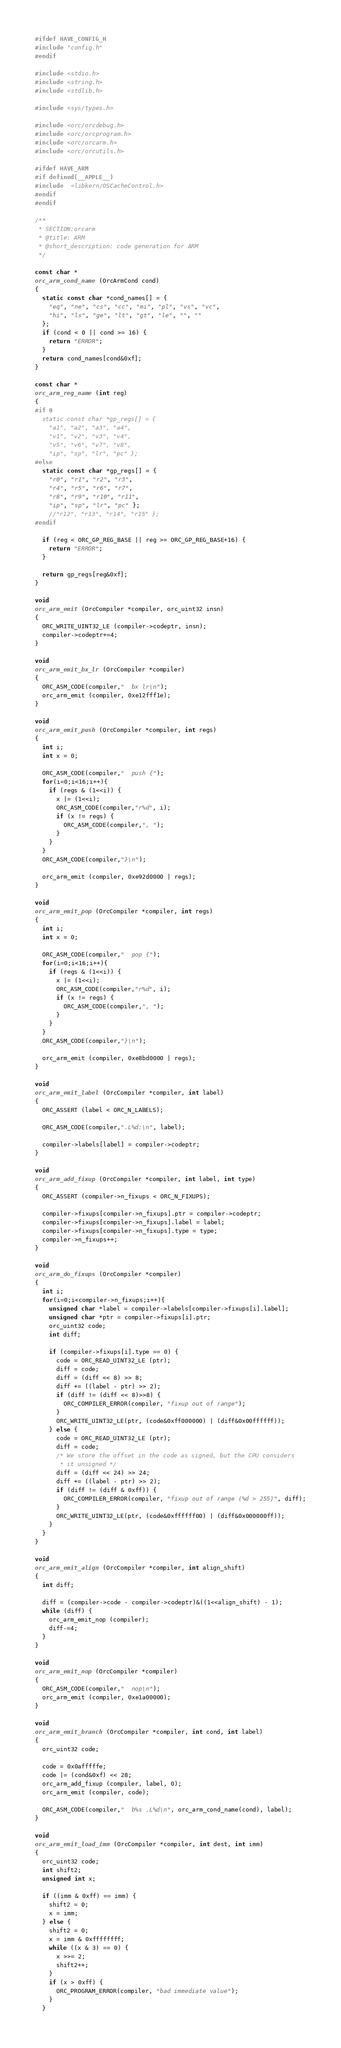<code> <loc_0><loc_0><loc_500><loc_500><_C_>
#ifdef HAVE_CONFIG_H
#include "config.h"
#endif

#include <stdio.h>
#include <string.h>
#include <stdlib.h>

#include <sys/types.h>

#include <orc/orcdebug.h>
#include <orc/orcprogram.h>
#include <orc/orcarm.h>
#include <orc/orcutils.h>

#ifdef HAVE_ARM
#if defined(__APPLE__)
#include  <libkern/OSCacheControl.h>
#endif
#endif

/**
 * SECTION:orcarm
 * @title: ARM
 * @short_description: code generation for ARM
 */

const char *
orc_arm_cond_name (OrcArmCond cond)
{
  static const char *cond_names[] = {
    "eq", "ne", "cs", "cc", "mi", "pl", "vs", "vc",
    "hi", "ls", "ge", "lt", "gt", "le", "", ""
  };
  if (cond < 0 || cond >= 16) {
    return "ERROR";
  }
  return cond_names[cond&0xf];
}

const char *
orc_arm_reg_name (int reg)
{
#if 0
  static const char *gp_regs[] = {
    "a1", "a2", "a3", "a4",
    "v1", "v2", "v3", "v4",
    "v5", "v6", "v7", "v8",
    "ip", "sp", "lr", "pc" };
#else
  static const char *gp_regs[] = {
    "r0", "r1", "r2", "r3",
    "r4", "r5", "r6", "r7",
    "r8", "r9", "r10", "r11",
    "ip", "sp", "lr", "pc" };
    //"r12", "r13", "r14", "r15" };
#endif

  if (reg < ORC_GP_REG_BASE || reg >= ORC_GP_REG_BASE+16) {
    return "ERROR";
  }

  return gp_regs[reg&0xf];
}

void
orc_arm_emit (OrcCompiler *compiler, orc_uint32 insn)
{
  ORC_WRITE_UINT32_LE (compiler->codeptr, insn);
  compiler->codeptr+=4;
}

void
orc_arm_emit_bx_lr (OrcCompiler *compiler)
{
  ORC_ASM_CODE(compiler,"  bx lr\n");
  orc_arm_emit (compiler, 0xe12fff1e);
}

void
orc_arm_emit_push (OrcCompiler *compiler, int regs)
{
  int i;
  int x = 0;

  ORC_ASM_CODE(compiler,"  push {");
  for(i=0;i<16;i++){
    if (regs & (1<<i)) {
      x |= (1<<i);
      ORC_ASM_CODE(compiler,"r%d", i);
      if (x != regs) {
        ORC_ASM_CODE(compiler,", ");
      }
    }
  }
  ORC_ASM_CODE(compiler,"}\n");

  orc_arm_emit (compiler, 0xe92d0000 | regs);
}

void
orc_arm_emit_pop (OrcCompiler *compiler, int regs)
{
  int i;
  int x = 0;

  ORC_ASM_CODE(compiler,"  pop {");
  for(i=0;i<16;i++){
    if (regs & (1<<i)) {
      x |= (1<<i);
      ORC_ASM_CODE(compiler,"r%d", i);
      if (x != regs) {
        ORC_ASM_CODE(compiler,", ");
      }
    }
  }
  ORC_ASM_CODE(compiler,"}\n");

  orc_arm_emit (compiler, 0xe8bd0000 | regs);
}

void
orc_arm_emit_label (OrcCompiler *compiler, int label)
{
  ORC_ASSERT (label < ORC_N_LABELS);

  ORC_ASM_CODE(compiler,".L%d:\n", label);

  compiler->labels[label] = compiler->codeptr;
}

void
orc_arm_add_fixup (OrcCompiler *compiler, int label, int type)
{
  ORC_ASSERT (compiler->n_fixups < ORC_N_FIXUPS);

  compiler->fixups[compiler->n_fixups].ptr = compiler->codeptr;
  compiler->fixups[compiler->n_fixups].label = label;
  compiler->fixups[compiler->n_fixups].type = type;
  compiler->n_fixups++;
}

void
orc_arm_do_fixups (OrcCompiler *compiler)
{
  int i;
  for(i=0;i<compiler->n_fixups;i++){
    unsigned char *label = compiler->labels[compiler->fixups[i].label];
    unsigned char *ptr = compiler->fixups[i].ptr;
    orc_uint32 code;
    int diff;

    if (compiler->fixups[i].type == 0) {
      code = ORC_READ_UINT32_LE (ptr);
      diff = code;
      diff = (diff << 8) >> 8;
      diff += ((label - ptr) >> 2);
      if (diff != (diff << 8)>>8) {
        ORC_COMPILER_ERROR(compiler, "fixup out of range");
      }
      ORC_WRITE_UINT32_LE(ptr, (code&0xff000000) | (diff&0x00ffffff));
    } else {
      code = ORC_READ_UINT32_LE (ptr);
      diff = code;
      /* We store the offset in the code as signed, but the CPU considers
       * it unsigned */
      diff = (diff << 24) >> 24;
      diff += ((label - ptr) >> 2);
      if (diff != (diff & 0xff)) {
        ORC_COMPILER_ERROR(compiler, "fixup out of range (%d > 255)", diff);
      }
      ORC_WRITE_UINT32_LE(ptr, (code&0xffffff00) | (diff&0x000000ff));
    }
  }
}

void
orc_arm_emit_align (OrcCompiler *compiler, int align_shift)
{
  int diff;

  diff = (compiler->code - compiler->codeptr)&((1<<align_shift) - 1);
  while (diff) {
    orc_arm_emit_nop (compiler);
    diff-=4;
  }
}

void
orc_arm_emit_nop (OrcCompiler *compiler)
{
  ORC_ASM_CODE(compiler,"  nop\n");
  orc_arm_emit (compiler, 0xe1a00000);
}

void
orc_arm_emit_branch (OrcCompiler *compiler, int cond, int label)
{
  orc_uint32 code;

  code = 0x0afffffe;
  code |= (cond&0xf) << 28;
  orc_arm_add_fixup (compiler, label, 0);
  orc_arm_emit (compiler, code);

  ORC_ASM_CODE(compiler,"  b%s .L%d\n", orc_arm_cond_name(cond), label);
}

void
orc_arm_emit_load_imm (OrcCompiler *compiler, int dest, int imm)
{
  orc_uint32 code;
  int shift2;
  unsigned int x;

  if ((imm & 0xff) == imm) {
    shift2 = 0;
    x = imm;
  } else {
    shift2 = 0;
    x = imm & 0xffffffff;
    while ((x & 3) == 0) {
      x >>= 2;
      shift2++;
    }
    if (x > 0xff) {
      ORC_PROGRAM_ERROR(compiler, "bad immediate value");
    }
  }
</code> 